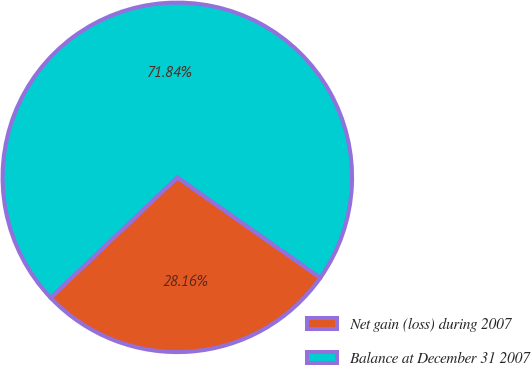Convert chart to OTSL. <chart><loc_0><loc_0><loc_500><loc_500><pie_chart><fcel>Net gain (loss) during 2007<fcel>Balance at December 31 2007<nl><fcel>28.16%<fcel>71.84%<nl></chart> 